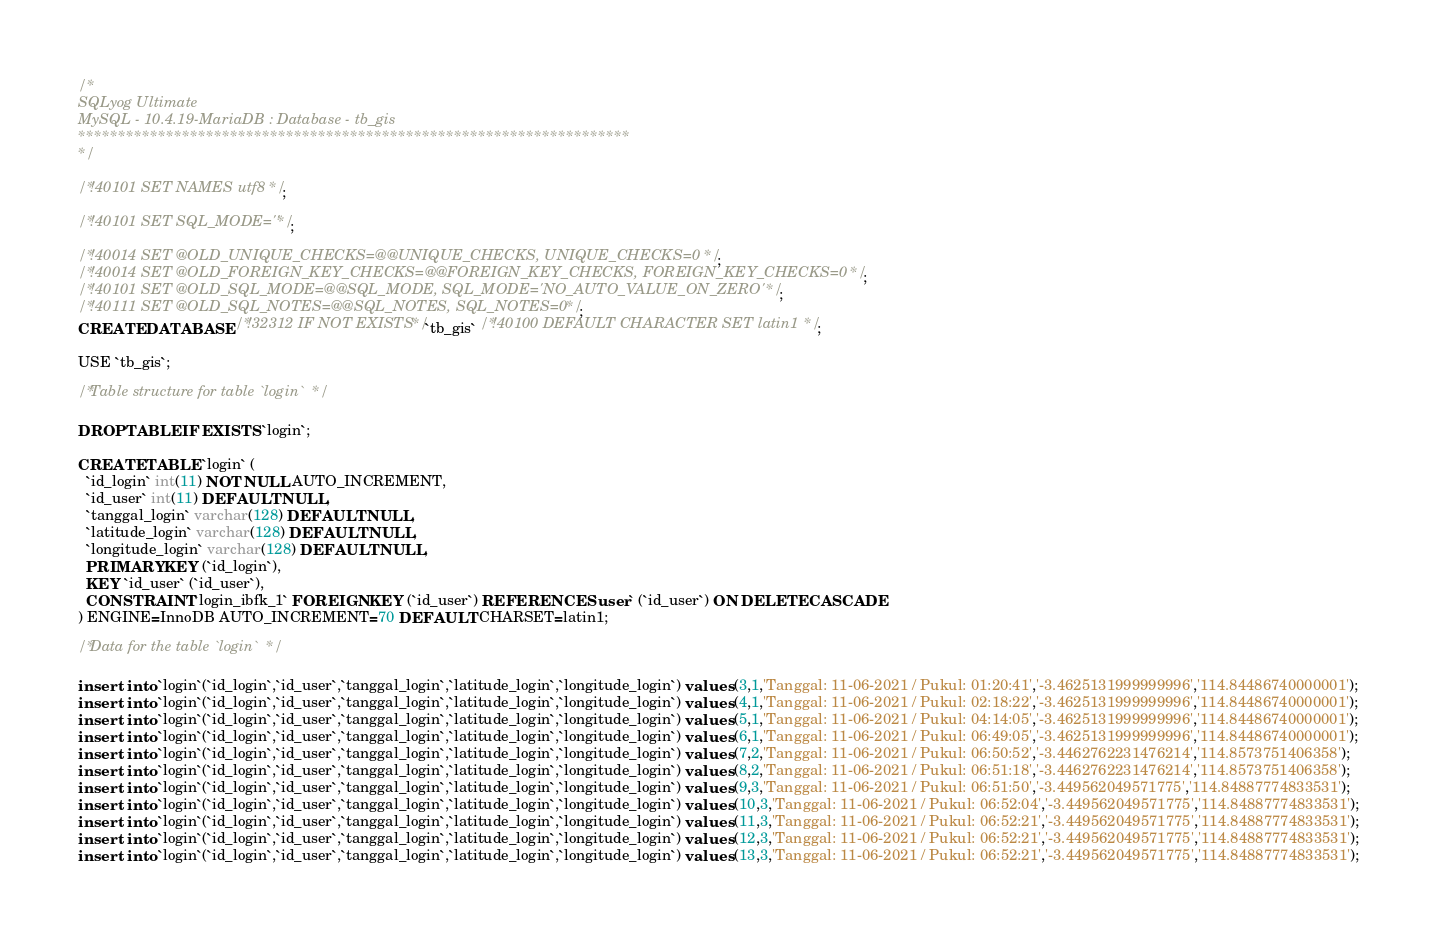Convert code to text. <code><loc_0><loc_0><loc_500><loc_500><_SQL_>/*
SQLyog Ultimate
MySQL - 10.4.19-MariaDB : Database - tb_gis
*********************************************************************
*/

/*!40101 SET NAMES utf8 */;

/*!40101 SET SQL_MODE=''*/;

/*!40014 SET @OLD_UNIQUE_CHECKS=@@UNIQUE_CHECKS, UNIQUE_CHECKS=0 */;
/*!40014 SET @OLD_FOREIGN_KEY_CHECKS=@@FOREIGN_KEY_CHECKS, FOREIGN_KEY_CHECKS=0 */;
/*!40101 SET @OLD_SQL_MODE=@@SQL_MODE, SQL_MODE='NO_AUTO_VALUE_ON_ZERO' */;
/*!40111 SET @OLD_SQL_NOTES=@@SQL_NOTES, SQL_NOTES=0 */;
CREATE DATABASE /*!32312 IF NOT EXISTS*/`tb_gis` /*!40100 DEFAULT CHARACTER SET latin1 */;

USE `tb_gis`;

/*Table structure for table `login` */

DROP TABLE IF EXISTS `login`;

CREATE TABLE `login` (
  `id_login` int(11) NOT NULL AUTO_INCREMENT,
  `id_user` int(11) DEFAULT NULL,
  `tanggal_login` varchar(128) DEFAULT NULL,
  `latitude_login` varchar(128) DEFAULT NULL,
  `longitude_login` varchar(128) DEFAULT NULL,
  PRIMARY KEY (`id_login`),
  KEY `id_user` (`id_user`),
  CONSTRAINT `login_ibfk_1` FOREIGN KEY (`id_user`) REFERENCES `user` (`id_user`) ON DELETE CASCADE
) ENGINE=InnoDB AUTO_INCREMENT=70 DEFAULT CHARSET=latin1;

/*Data for the table `login` */

insert  into `login`(`id_login`,`id_user`,`tanggal_login`,`latitude_login`,`longitude_login`) values (3,1,'Tanggal: 11-06-2021 / Pukul: 01:20:41','-3.4625131999999996','114.84486740000001');
insert  into `login`(`id_login`,`id_user`,`tanggal_login`,`latitude_login`,`longitude_login`) values (4,1,'Tanggal: 11-06-2021 / Pukul: 02:18:22','-3.4625131999999996','114.84486740000001');
insert  into `login`(`id_login`,`id_user`,`tanggal_login`,`latitude_login`,`longitude_login`) values (5,1,'Tanggal: 11-06-2021 / Pukul: 04:14:05','-3.4625131999999996','114.84486740000001');
insert  into `login`(`id_login`,`id_user`,`tanggal_login`,`latitude_login`,`longitude_login`) values (6,1,'Tanggal: 11-06-2021 / Pukul: 06:49:05','-3.4625131999999996','114.84486740000001');
insert  into `login`(`id_login`,`id_user`,`tanggal_login`,`latitude_login`,`longitude_login`) values (7,2,'Tanggal: 11-06-2021 / Pukul: 06:50:52','-3.4462762231476214','114.8573751406358');
insert  into `login`(`id_login`,`id_user`,`tanggal_login`,`latitude_login`,`longitude_login`) values (8,2,'Tanggal: 11-06-2021 / Pukul: 06:51:18','-3.4462762231476214','114.8573751406358');
insert  into `login`(`id_login`,`id_user`,`tanggal_login`,`latitude_login`,`longitude_login`) values (9,3,'Tanggal: 11-06-2021 / Pukul: 06:51:50','-3.449562049571775','114.84887774833531');
insert  into `login`(`id_login`,`id_user`,`tanggal_login`,`latitude_login`,`longitude_login`) values (10,3,'Tanggal: 11-06-2021 / Pukul: 06:52:04','-3.449562049571775','114.84887774833531');
insert  into `login`(`id_login`,`id_user`,`tanggal_login`,`latitude_login`,`longitude_login`) values (11,3,'Tanggal: 11-06-2021 / Pukul: 06:52:21','-3.449562049571775','114.84887774833531');
insert  into `login`(`id_login`,`id_user`,`tanggal_login`,`latitude_login`,`longitude_login`) values (12,3,'Tanggal: 11-06-2021 / Pukul: 06:52:21','-3.449562049571775','114.84887774833531');
insert  into `login`(`id_login`,`id_user`,`tanggal_login`,`latitude_login`,`longitude_login`) values (13,3,'Tanggal: 11-06-2021 / Pukul: 06:52:21','-3.449562049571775','114.84887774833531');</code> 